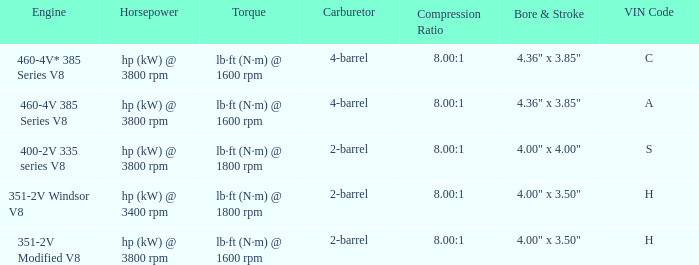What are the bore & stroke specifications for an engine with 4-barrel carburetor and VIN code of A? 4.36" x 3.85". Could you parse the entire table as a dict? {'header': ['Engine', 'Horsepower', 'Torque', 'Carburetor', 'Compression Ratio', 'Bore & Stroke', 'VIN Code'], 'rows': [['460-4V* 385 Series V8', 'hp (kW) @ 3800 rpm', 'lb·ft (N·m) @ 1600 rpm', '4-barrel', '8.00:1', '4.36" x 3.85"', 'C'], ['460-4V 385 Series V8', 'hp (kW) @ 3800 rpm', 'lb·ft (N·m) @ 1600 rpm', '4-barrel', '8.00:1', '4.36" x 3.85"', 'A'], ['400-2V 335 series V8', 'hp (kW) @ 3800 rpm', 'lb·ft (N·m) @ 1800 rpm', '2-barrel', '8.00:1', '4.00" x 4.00"', 'S'], ['351-2V Windsor V8', 'hp (kW) @ 3400 rpm', 'lb·ft (N·m) @ 1800 rpm', '2-barrel', '8.00:1', '4.00" x 3.50"', 'H'], ['351-2V Modified V8', 'hp (kW) @ 3800 rpm', 'lb·ft (N·m) @ 1600 rpm', '2-barrel', '8.00:1', '4.00" x 3.50"', 'H']]} 